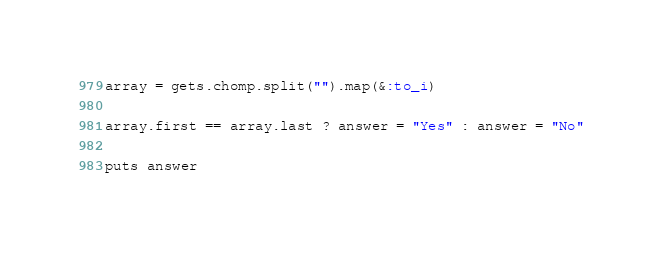<code> <loc_0><loc_0><loc_500><loc_500><_Ruby_>array = gets.chomp.split("").map(&:to_i)

array.first == array.last ? answer = "Yes" : answer = "No"

puts answer</code> 